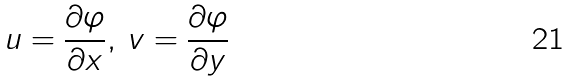<formula> <loc_0><loc_0><loc_500><loc_500>u = \frac { \partial \varphi } { \partial x } , \, v = \frac { \partial \varphi } { \partial y }</formula> 